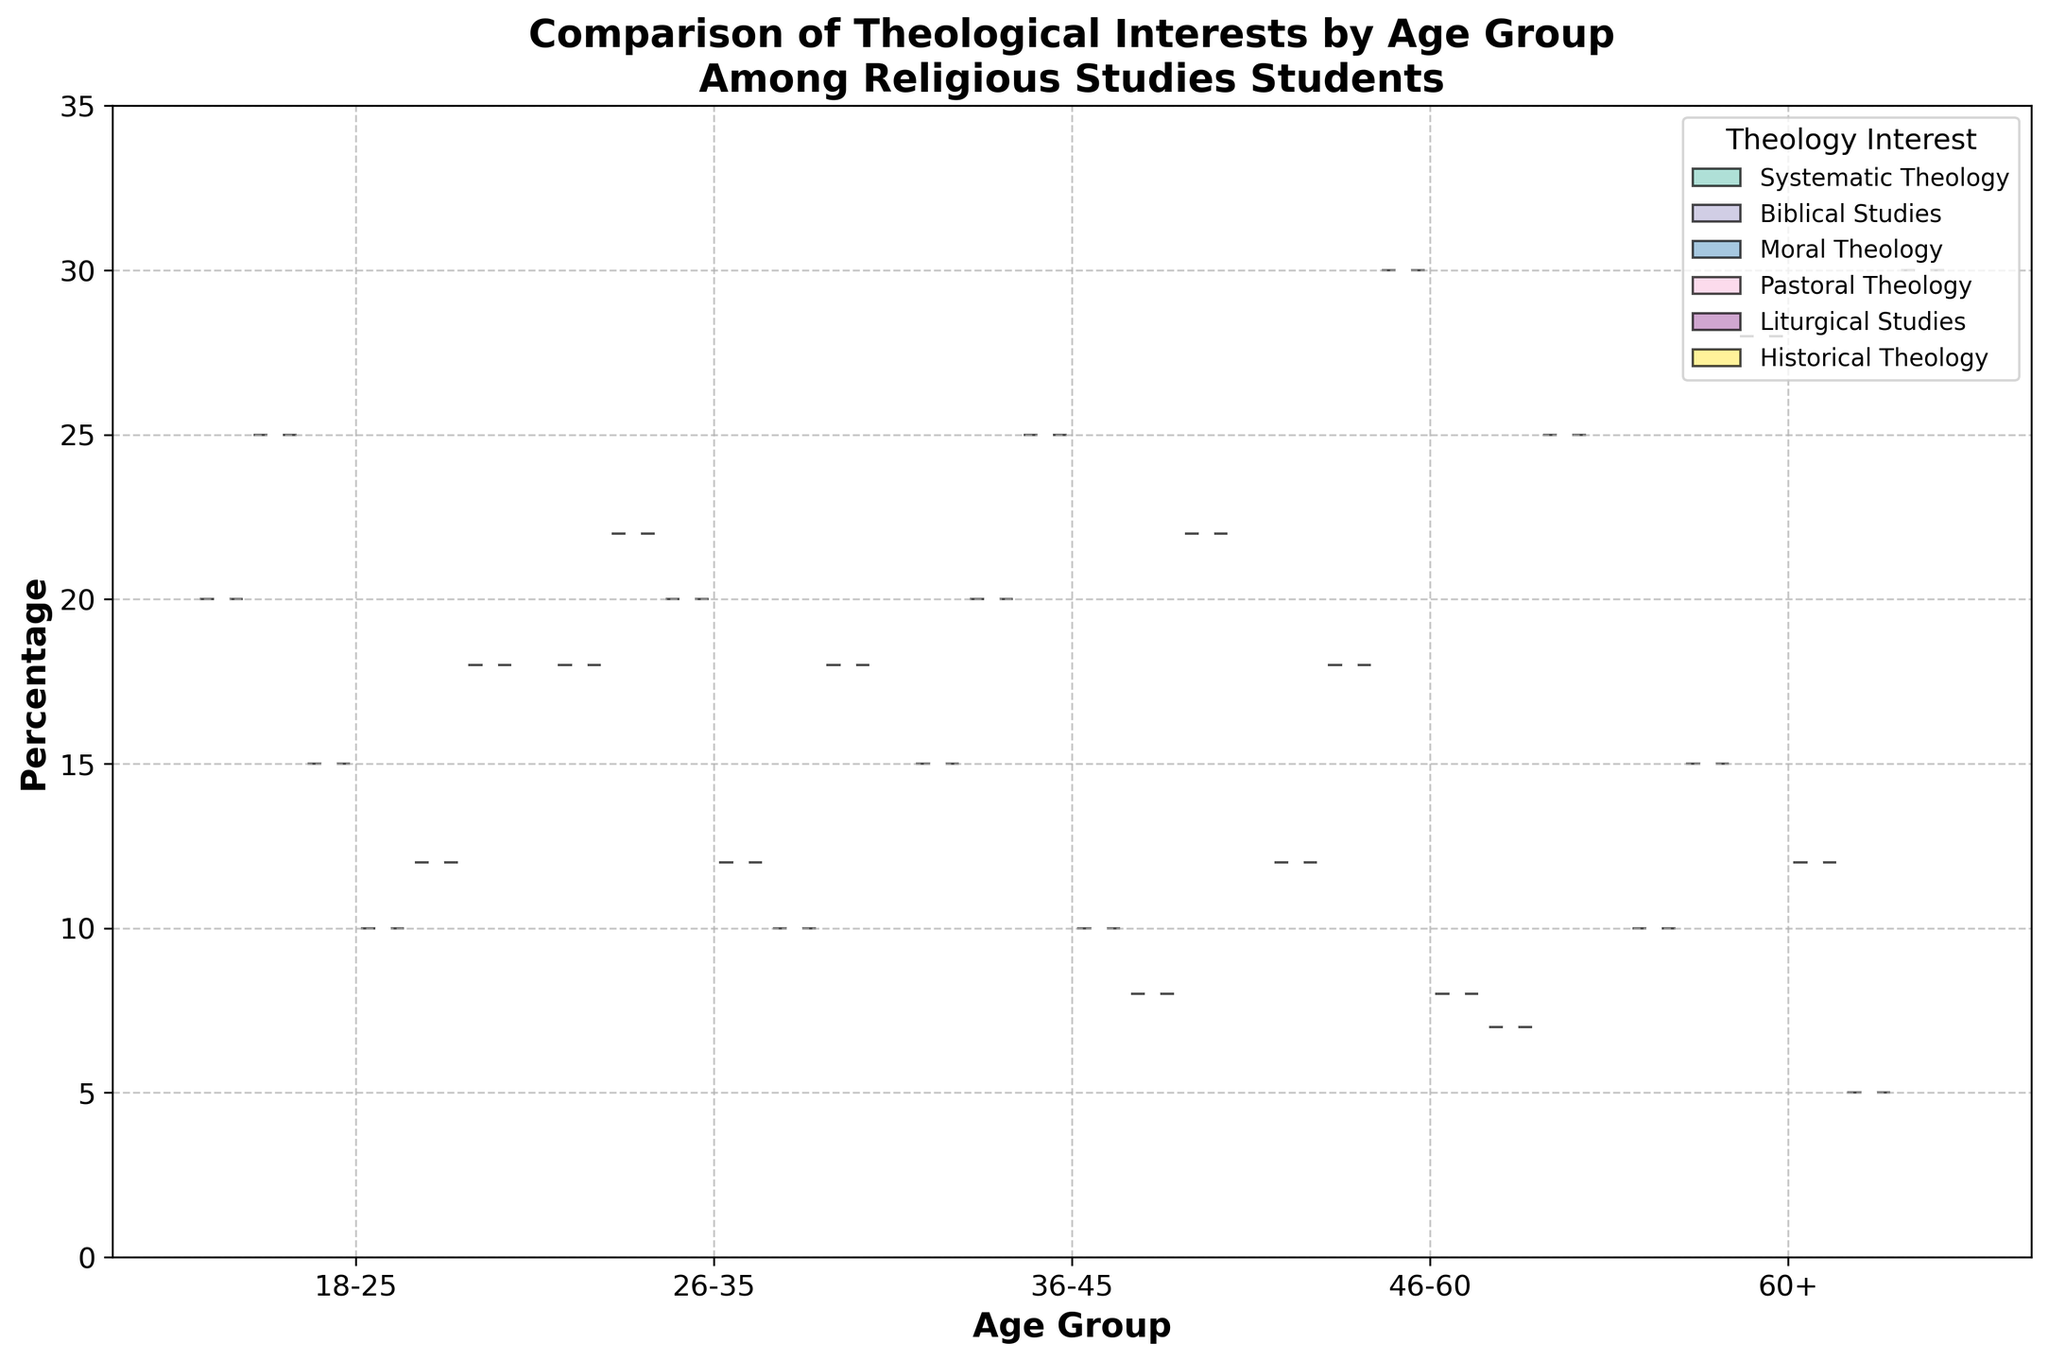What is the title of the figure? The title of the figure is often prominently displayed on top of the plot. For this particular figure, the title directly describes the comparison being presented.
Answer: Comparison of Theological Interests by Age Group Among Religious Studies Students What is the percentage range shown on the y-axis? The y-axis typically indicates the range for the data presented. By looking at the y-axis labels, you can identify the range of values provided.
Answer: 0 to 35 Which age group has the highest median percentage for Moral Theology? To determine this, locate the median markers (white circles) within the corresponding Moral Theology sections of each age group and compare their positions.
Answer: 46-60 How does the interest in Systematic Theology change with age? To assess trends across age groups, we would look at the general positioning and spread of the Systematic Theology data for each age group and describe the changes observed.
Answer: It generally decreases with age What is the interquartile range (IQR) for Biblical Studies in the 18-25 age group? The IQR is the range between the 25th percentile (Q1) and the 75th percentile (Q3). Locate these points from the box plot within the violin plot for the specified age group and calculate the difference.
Answer: Approx. 9% (Q1 around 20%, Q3 around 29%) Which theology interest has the greatest variability in the 36-45 age group? Variability is indicated by the width and spread of the violin plot and the distance between whiskers in the box plot. Look at these indicators to identify the theology with the broadest spread.
Answer: Moral Theology What are the median percentages for Historical Theology across all age groups? Locate the median markers (white circles) in the sections for Historical Theology across all age groups and list them.
Answer: 18%, 18%, 22%, 25%, 30% In the 60+ age group, which theological interest has the smallest interquartile range (IQR)? Compare the lengths of the boxes within the violin plots for each theological interest in the 60+ age group to identify the smallest IQR.
Answer: Liturgical Studies 